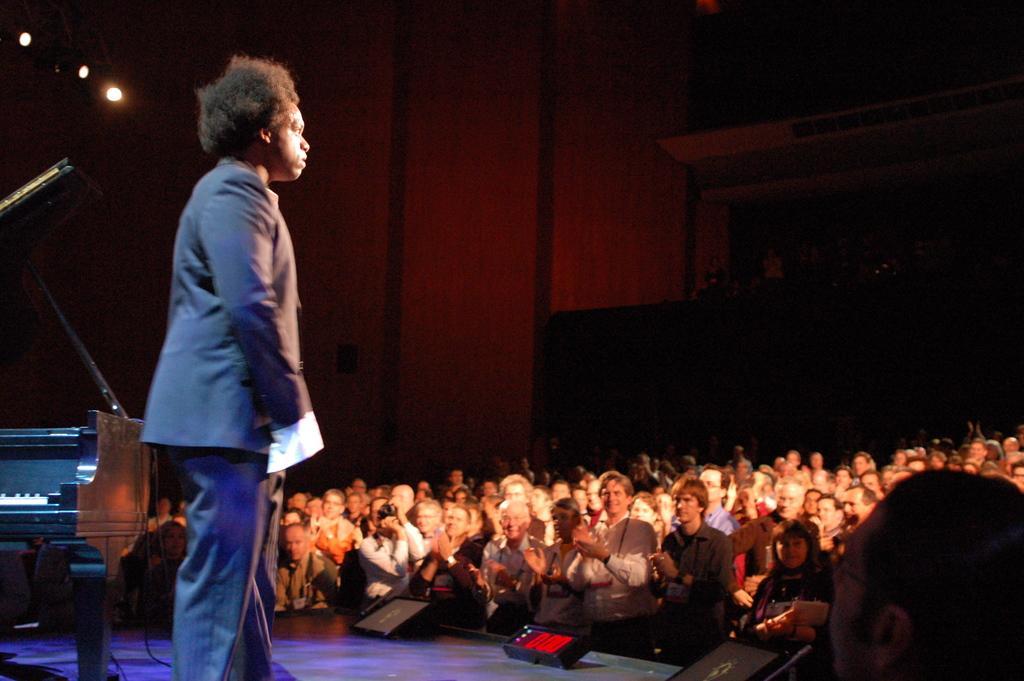In one or two sentences, can you explain what this image depicts? In this image we can see a person wearing suit standing on stage, there is piano, microphone and some sound boxes on stage and on right side of the image there are some persons sitting in a row and top of the image there are some lights and wooden wall. 